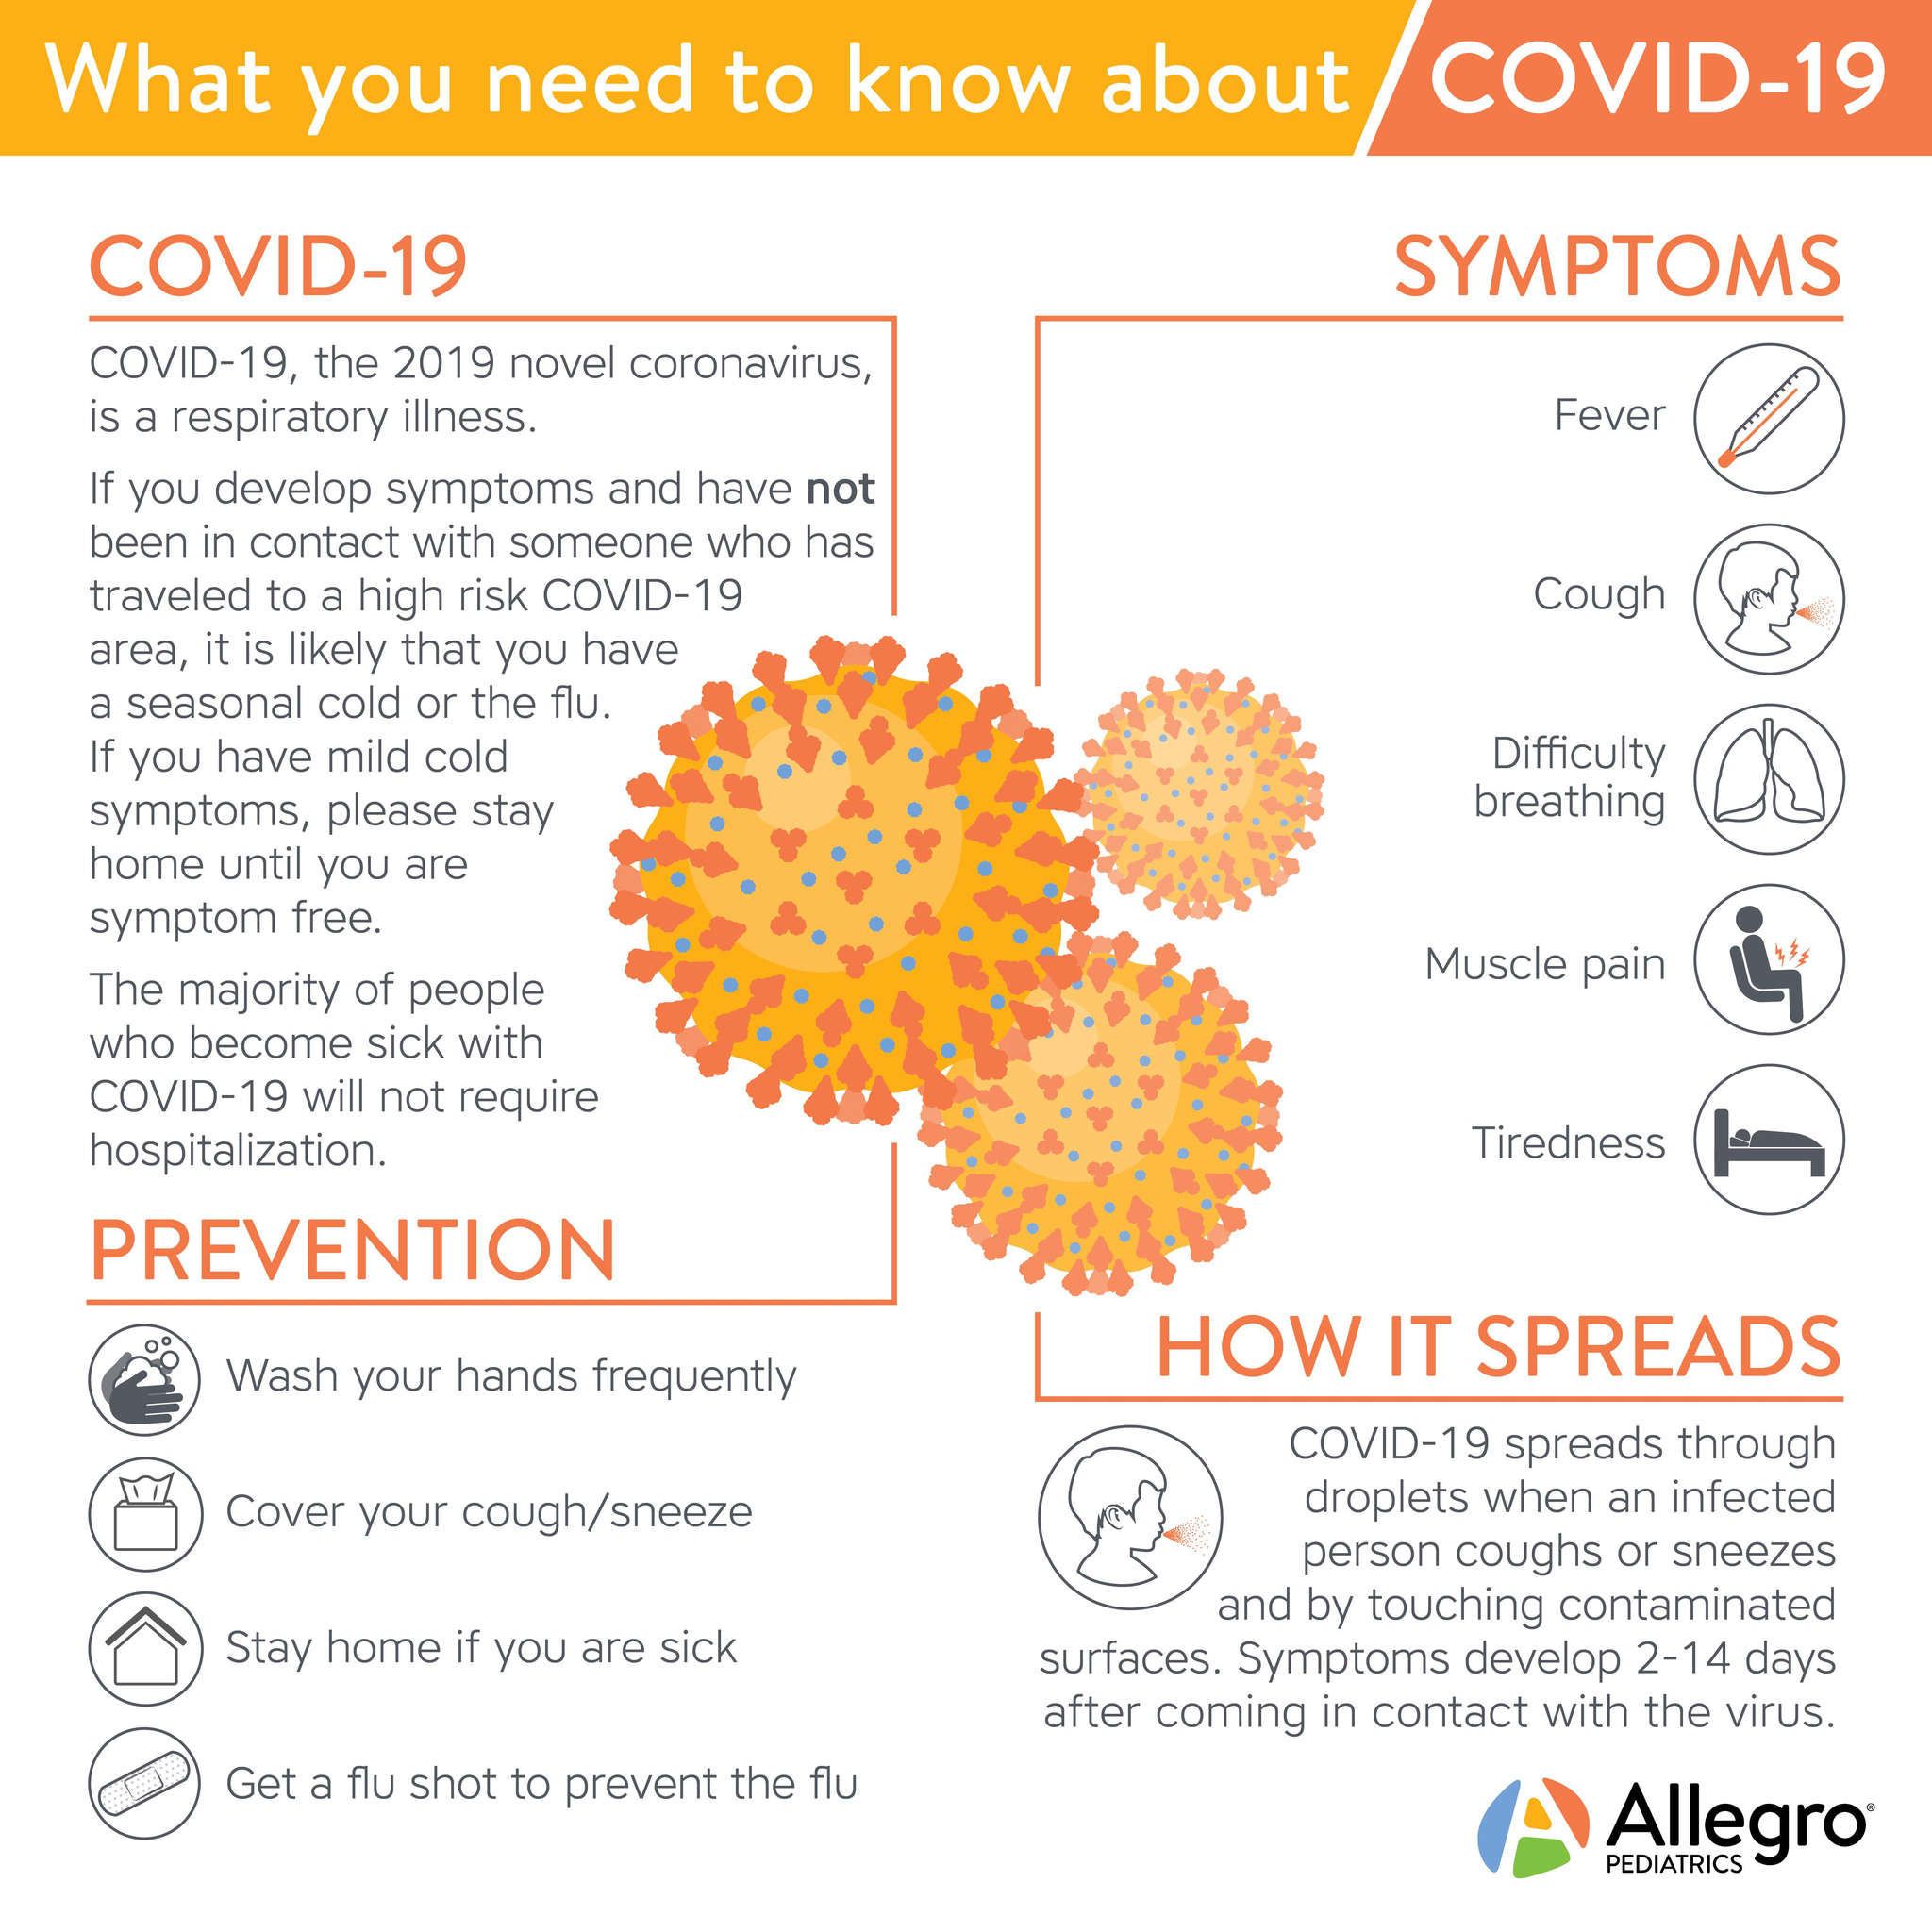Give some essential details in this illustration. The symptoms of COVID-19 are fever, cough, and difficulty breathing, with fever being the first reported symptom. 